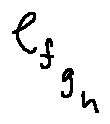Convert formula to latex. <formula><loc_0><loc_0><loc_500><loc_500>e _ { f _ { g _ { h } } }</formula> 